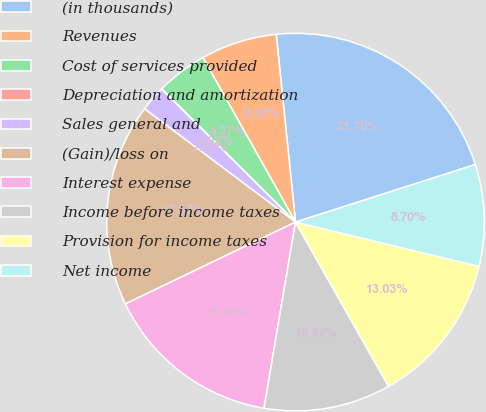Convert chart. <chart><loc_0><loc_0><loc_500><loc_500><pie_chart><fcel>(in thousands)<fcel>Revenues<fcel>Cost of services provided<fcel>Depreciation and amortization<fcel>Sales general and<fcel>(Gain)/loss on<fcel>Interest expense<fcel>Income before income taxes<fcel>Provision for income taxes<fcel>Net income<nl><fcel>21.7%<fcel>6.53%<fcel>4.37%<fcel>0.03%<fcel>2.2%<fcel>17.37%<fcel>15.2%<fcel>10.87%<fcel>13.03%<fcel>8.7%<nl></chart> 